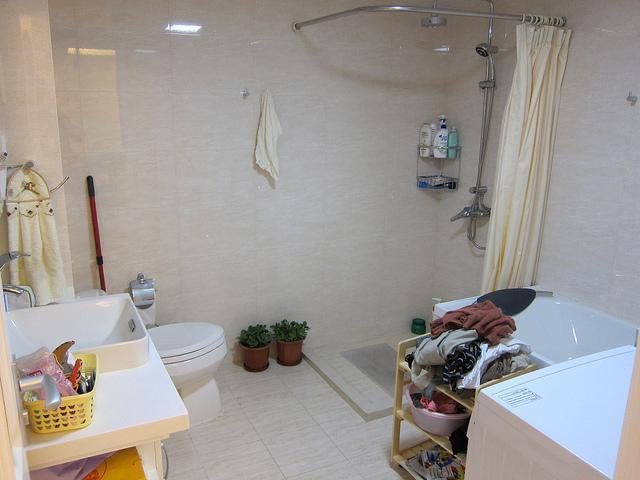How many plants are in the picture?
Give a very brief answer. 2. 